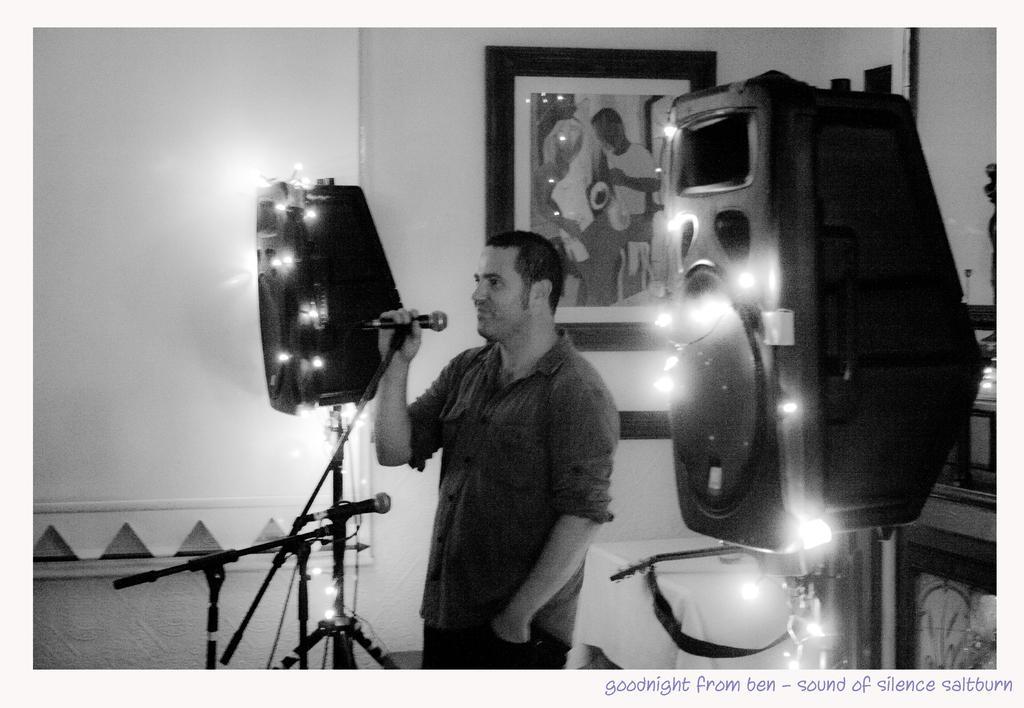Could you give a brief overview of what you see in this image? In this image there is a person standing and holding microphone. At the left and at the right there are speakers, at the back there are photo frames on the wall. 